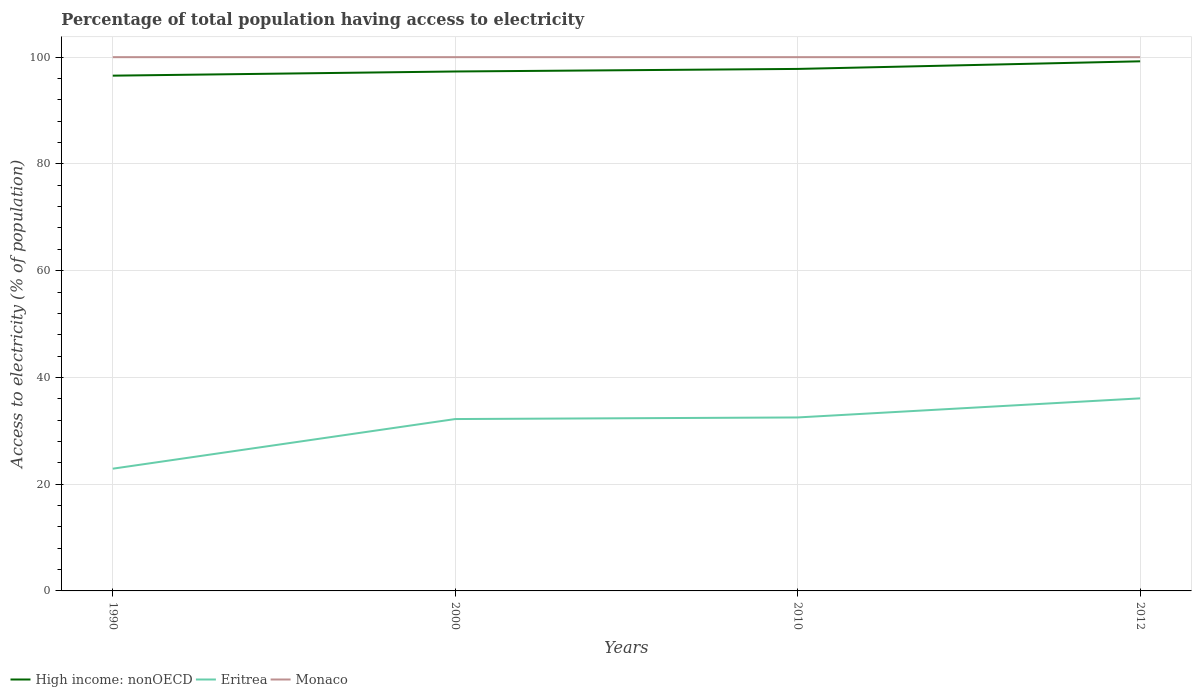Does the line corresponding to Monaco intersect with the line corresponding to Eritrea?
Provide a short and direct response. No. Is the number of lines equal to the number of legend labels?
Provide a succinct answer. Yes. Across all years, what is the maximum percentage of population that have access to electricity in High income: nonOECD?
Make the answer very short. 96.53. What is the total percentage of population that have access to electricity in High income: nonOECD in the graph?
Your answer should be very brief. -1.91. What is the difference between the highest and the second highest percentage of population that have access to electricity in Monaco?
Offer a very short reply. 0. What is the difference between the highest and the lowest percentage of population that have access to electricity in Monaco?
Make the answer very short. 0. Is the percentage of population that have access to electricity in Eritrea strictly greater than the percentage of population that have access to electricity in Monaco over the years?
Offer a very short reply. Yes. How many lines are there?
Give a very brief answer. 3. How many years are there in the graph?
Make the answer very short. 4. Does the graph contain any zero values?
Offer a terse response. No. Where does the legend appear in the graph?
Provide a short and direct response. Bottom left. How many legend labels are there?
Ensure brevity in your answer.  3. How are the legend labels stacked?
Ensure brevity in your answer.  Horizontal. What is the title of the graph?
Give a very brief answer. Percentage of total population having access to electricity. Does "Myanmar" appear as one of the legend labels in the graph?
Give a very brief answer. No. What is the label or title of the X-axis?
Provide a short and direct response. Years. What is the label or title of the Y-axis?
Offer a very short reply. Access to electricity (% of population). What is the Access to electricity (% of population) of High income: nonOECD in 1990?
Offer a terse response. 96.53. What is the Access to electricity (% of population) in Eritrea in 1990?
Offer a terse response. 22.9. What is the Access to electricity (% of population) of High income: nonOECD in 2000?
Offer a terse response. 97.31. What is the Access to electricity (% of population) in Eritrea in 2000?
Offer a terse response. 32.2. What is the Access to electricity (% of population) of High income: nonOECD in 2010?
Your answer should be very brief. 97.8. What is the Access to electricity (% of population) of Eritrea in 2010?
Your answer should be compact. 32.5. What is the Access to electricity (% of population) in Monaco in 2010?
Your answer should be compact. 100. What is the Access to electricity (% of population) of High income: nonOECD in 2012?
Offer a very short reply. 99.22. What is the Access to electricity (% of population) of Eritrea in 2012?
Provide a short and direct response. 36.08. What is the Access to electricity (% of population) of Monaco in 2012?
Provide a short and direct response. 100. Across all years, what is the maximum Access to electricity (% of population) of High income: nonOECD?
Offer a very short reply. 99.22. Across all years, what is the maximum Access to electricity (% of population) of Eritrea?
Give a very brief answer. 36.08. Across all years, what is the minimum Access to electricity (% of population) in High income: nonOECD?
Give a very brief answer. 96.53. Across all years, what is the minimum Access to electricity (% of population) in Eritrea?
Ensure brevity in your answer.  22.9. What is the total Access to electricity (% of population) of High income: nonOECD in the graph?
Your response must be concise. 390.87. What is the total Access to electricity (% of population) of Eritrea in the graph?
Offer a very short reply. 123.68. What is the total Access to electricity (% of population) of Monaco in the graph?
Your response must be concise. 400. What is the difference between the Access to electricity (% of population) in High income: nonOECD in 1990 and that in 2000?
Your answer should be compact. -0.78. What is the difference between the Access to electricity (% of population) of Monaco in 1990 and that in 2000?
Ensure brevity in your answer.  0. What is the difference between the Access to electricity (% of population) of High income: nonOECD in 1990 and that in 2010?
Your answer should be very brief. -1.26. What is the difference between the Access to electricity (% of population) of Eritrea in 1990 and that in 2010?
Offer a terse response. -9.6. What is the difference between the Access to electricity (% of population) of High income: nonOECD in 1990 and that in 2012?
Keep it short and to the point. -2.69. What is the difference between the Access to electricity (% of population) in Eritrea in 1990 and that in 2012?
Offer a very short reply. -13.18. What is the difference between the Access to electricity (% of population) in Monaco in 1990 and that in 2012?
Give a very brief answer. 0. What is the difference between the Access to electricity (% of population) of High income: nonOECD in 2000 and that in 2010?
Give a very brief answer. -0.48. What is the difference between the Access to electricity (% of population) of Monaco in 2000 and that in 2010?
Keep it short and to the point. 0. What is the difference between the Access to electricity (% of population) in High income: nonOECD in 2000 and that in 2012?
Your answer should be very brief. -1.91. What is the difference between the Access to electricity (% of population) of Eritrea in 2000 and that in 2012?
Provide a succinct answer. -3.88. What is the difference between the Access to electricity (% of population) in High income: nonOECD in 2010 and that in 2012?
Make the answer very short. -1.43. What is the difference between the Access to electricity (% of population) of Eritrea in 2010 and that in 2012?
Provide a short and direct response. -3.58. What is the difference between the Access to electricity (% of population) in Monaco in 2010 and that in 2012?
Your response must be concise. 0. What is the difference between the Access to electricity (% of population) of High income: nonOECD in 1990 and the Access to electricity (% of population) of Eritrea in 2000?
Provide a short and direct response. 64.33. What is the difference between the Access to electricity (% of population) in High income: nonOECD in 1990 and the Access to electricity (% of population) in Monaco in 2000?
Ensure brevity in your answer.  -3.47. What is the difference between the Access to electricity (% of population) of Eritrea in 1990 and the Access to electricity (% of population) of Monaco in 2000?
Offer a very short reply. -77.1. What is the difference between the Access to electricity (% of population) in High income: nonOECD in 1990 and the Access to electricity (% of population) in Eritrea in 2010?
Ensure brevity in your answer.  64.03. What is the difference between the Access to electricity (% of population) of High income: nonOECD in 1990 and the Access to electricity (% of population) of Monaco in 2010?
Offer a terse response. -3.47. What is the difference between the Access to electricity (% of population) of Eritrea in 1990 and the Access to electricity (% of population) of Monaco in 2010?
Keep it short and to the point. -77.1. What is the difference between the Access to electricity (% of population) of High income: nonOECD in 1990 and the Access to electricity (% of population) of Eritrea in 2012?
Make the answer very short. 60.46. What is the difference between the Access to electricity (% of population) of High income: nonOECD in 1990 and the Access to electricity (% of population) of Monaco in 2012?
Ensure brevity in your answer.  -3.47. What is the difference between the Access to electricity (% of population) in Eritrea in 1990 and the Access to electricity (% of population) in Monaco in 2012?
Give a very brief answer. -77.1. What is the difference between the Access to electricity (% of population) of High income: nonOECD in 2000 and the Access to electricity (% of population) of Eritrea in 2010?
Your answer should be compact. 64.81. What is the difference between the Access to electricity (% of population) of High income: nonOECD in 2000 and the Access to electricity (% of population) of Monaco in 2010?
Your answer should be very brief. -2.69. What is the difference between the Access to electricity (% of population) in Eritrea in 2000 and the Access to electricity (% of population) in Monaco in 2010?
Your answer should be very brief. -67.8. What is the difference between the Access to electricity (% of population) of High income: nonOECD in 2000 and the Access to electricity (% of population) of Eritrea in 2012?
Keep it short and to the point. 61.24. What is the difference between the Access to electricity (% of population) of High income: nonOECD in 2000 and the Access to electricity (% of population) of Monaco in 2012?
Ensure brevity in your answer.  -2.69. What is the difference between the Access to electricity (% of population) of Eritrea in 2000 and the Access to electricity (% of population) of Monaco in 2012?
Make the answer very short. -67.8. What is the difference between the Access to electricity (% of population) in High income: nonOECD in 2010 and the Access to electricity (% of population) in Eritrea in 2012?
Make the answer very short. 61.72. What is the difference between the Access to electricity (% of population) in High income: nonOECD in 2010 and the Access to electricity (% of population) in Monaco in 2012?
Keep it short and to the point. -2.2. What is the difference between the Access to electricity (% of population) of Eritrea in 2010 and the Access to electricity (% of population) of Monaco in 2012?
Your answer should be very brief. -67.5. What is the average Access to electricity (% of population) of High income: nonOECD per year?
Your answer should be very brief. 97.72. What is the average Access to electricity (% of population) in Eritrea per year?
Your response must be concise. 30.92. What is the average Access to electricity (% of population) in Monaco per year?
Keep it short and to the point. 100. In the year 1990, what is the difference between the Access to electricity (% of population) in High income: nonOECD and Access to electricity (% of population) in Eritrea?
Give a very brief answer. 73.63. In the year 1990, what is the difference between the Access to electricity (% of population) in High income: nonOECD and Access to electricity (% of population) in Monaco?
Your response must be concise. -3.47. In the year 1990, what is the difference between the Access to electricity (% of population) in Eritrea and Access to electricity (% of population) in Monaco?
Keep it short and to the point. -77.1. In the year 2000, what is the difference between the Access to electricity (% of population) in High income: nonOECD and Access to electricity (% of population) in Eritrea?
Provide a short and direct response. 65.11. In the year 2000, what is the difference between the Access to electricity (% of population) of High income: nonOECD and Access to electricity (% of population) of Monaco?
Offer a very short reply. -2.69. In the year 2000, what is the difference between the Access to electricity (% of population) in Eritrea and Access to electricity (% of population) in Monaco?
Offer a terse response. -67.8. In the year 2010, what is the difference between the Access to electricity (% of population) of High income: nonOECD and Access to electricity (% of population) of Eritrea?
Ensure brevity in your answer.  65.3. In the year 2010, what is the difference between the Access to electricity (% of population) of High income: nonOECD and Access to electricity (% of population) of Monaco?
Keep it short and to the point. -2.2. In the year 2010, what is the difference between the Access to electricity (% of population) of Eritrea and Access to electricity (% of population) of Monaco?
Your answer should be very brief. -67.5. In the year 2012, what is the difference between the Access to electricity (% of population) of High income: nonOECD and Access to electricity (% of population) of Eritrea?
Keep it short and to the point. 63.14. In the year 2012, what is the difference between the Access to electricity (% of population) in High income: nonOECD and Access to electricity (% of population) in Monaco?
Your response must be concise. -0.78. In the year 2012, what is the difference between the Access to electricity (% of population) in Eritrea and Access to electricity (% of population) in Monaco?
Your response must be concise. -63.92. What is the ratio of the Access to electricity (% of population) in High income: nonOECD in 1990 to that in 2000?
Ensure brevity in your answer.  0.99. What is the ratio of the Access to electricity (% of population) in Eritrea in 1990 to that in 2000?
Ensure brevity in your answer.  0.71. What is the ratio of the Access to electricity (% of population) in Monaco in 1990 to that in 2000?
Your answer should be very brief. 1. What is the ratio of the Access to electricity (% of population) in High income: nonOECD in 1990 to that in 2010?
Your response must be concise. 0.99. What is the ratio of the Access to electricity (% of population) of Eritrea in 1990 to that in 2010?
Offer a very short reply. 0.7. What is the ratio of the Access to electricity (% of population) in Monaco in 1990 to that in 2010?
Your answer should be very brief. 1. What is the ratio of the Access to electricity (% of population) in High income: nonOECD in 1990 to that in 2012?
Offer a terse response. 0.97. What is the ratio of the Access to electricity (% of population) of Eritrea in 1990 to that in 2012?
Your answer should be compact. 0.63. What is the ratio of the Access to electricity (% of population) in Monaco in 1990 to that in 2012?
Offer a very short reply. 1. What is the ratio of the Access to electricity (% of population) in High income: nonOECD in 2000 to that in 2010?
Provide a short and direct response. 1. What is the ratio of the Access to electricity (% of population) in Monaco in 2000 to that in 2010?
Your answer should be compact. 1. What is the ratio of the Access to electricity (% of population) of High income: nonOECD in 2000 to that in 2012?
Offer a terse response. 0.98. What is the ratio of the Access to electricity (% of population) of Eritrea in 2000 to that in 2012?
Your answer should be very brief. 0.89. What is the ratio of the Access to electricity (% of population) in Monaco in 2000 to that in 2012?
Give a very brief answer. 1. What is the ratio of the Access to electricity (% of population) in High income: nonOECD in 2010 to that in 2012?
Offer a very short reply. 0.99. What is the ratio of the Access to electricity (% of population) of Eritrea in 2010 to that in 2012?
Your answer should be compact. 0.9. What is the difference between the highest and the second highest Access to electricity (% of population) in High income: nonOECD?
Give a very brief answer. 1.43. What is the difference between the highest and the second highest Access to electricity (% of population) of Eritrea?
Offer a very short reply. 3.58. What is the difference between the highest and the second highest Access to electricity (% of population) in Monaco?
Your response must be concise. 0. What is the difference between the highest and the lowest Access to electricity (% of population) in High income: nonOECD?
Offer a terse response. 2.69. What is the difference between the highest and the lowest Access to electricity (% of population) of Eritrea?
Keep it short and to the point. 13.18. What is the difference between the highest and the lowest Access to electricity (% of population) in Monaco?
Your answer should be very brief. 0. 